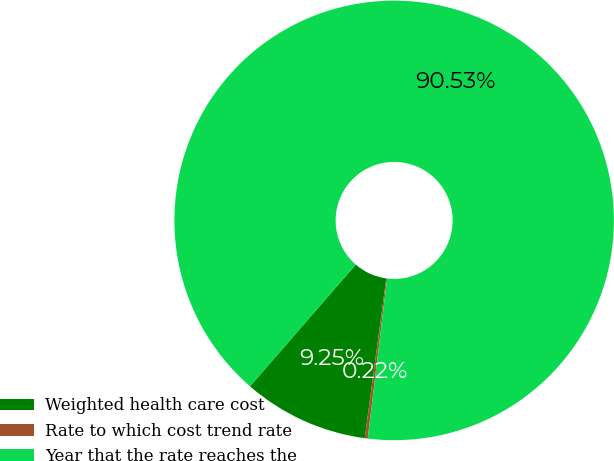Convert chart. <chart><loc_0><loc_0><loc_500><loc_500><pie_chart><fcel>Weighted health care cost<fcel>Rate to which cost trend rate<fcel>Year that the rate reaches the<nl><fcel>9.25%<fcel>0.22%<fcel>90.52%<nl></chart> 